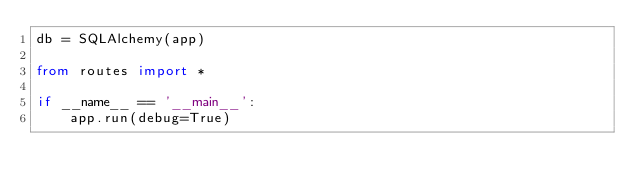Convert code to text. <code><loc_0><loc_0><loc_500><loc_500><_Python_>db = SQLAlchemy(app)

from routes import *

if __name__ == '__main__':
    app.run(debug=True)
</code> 